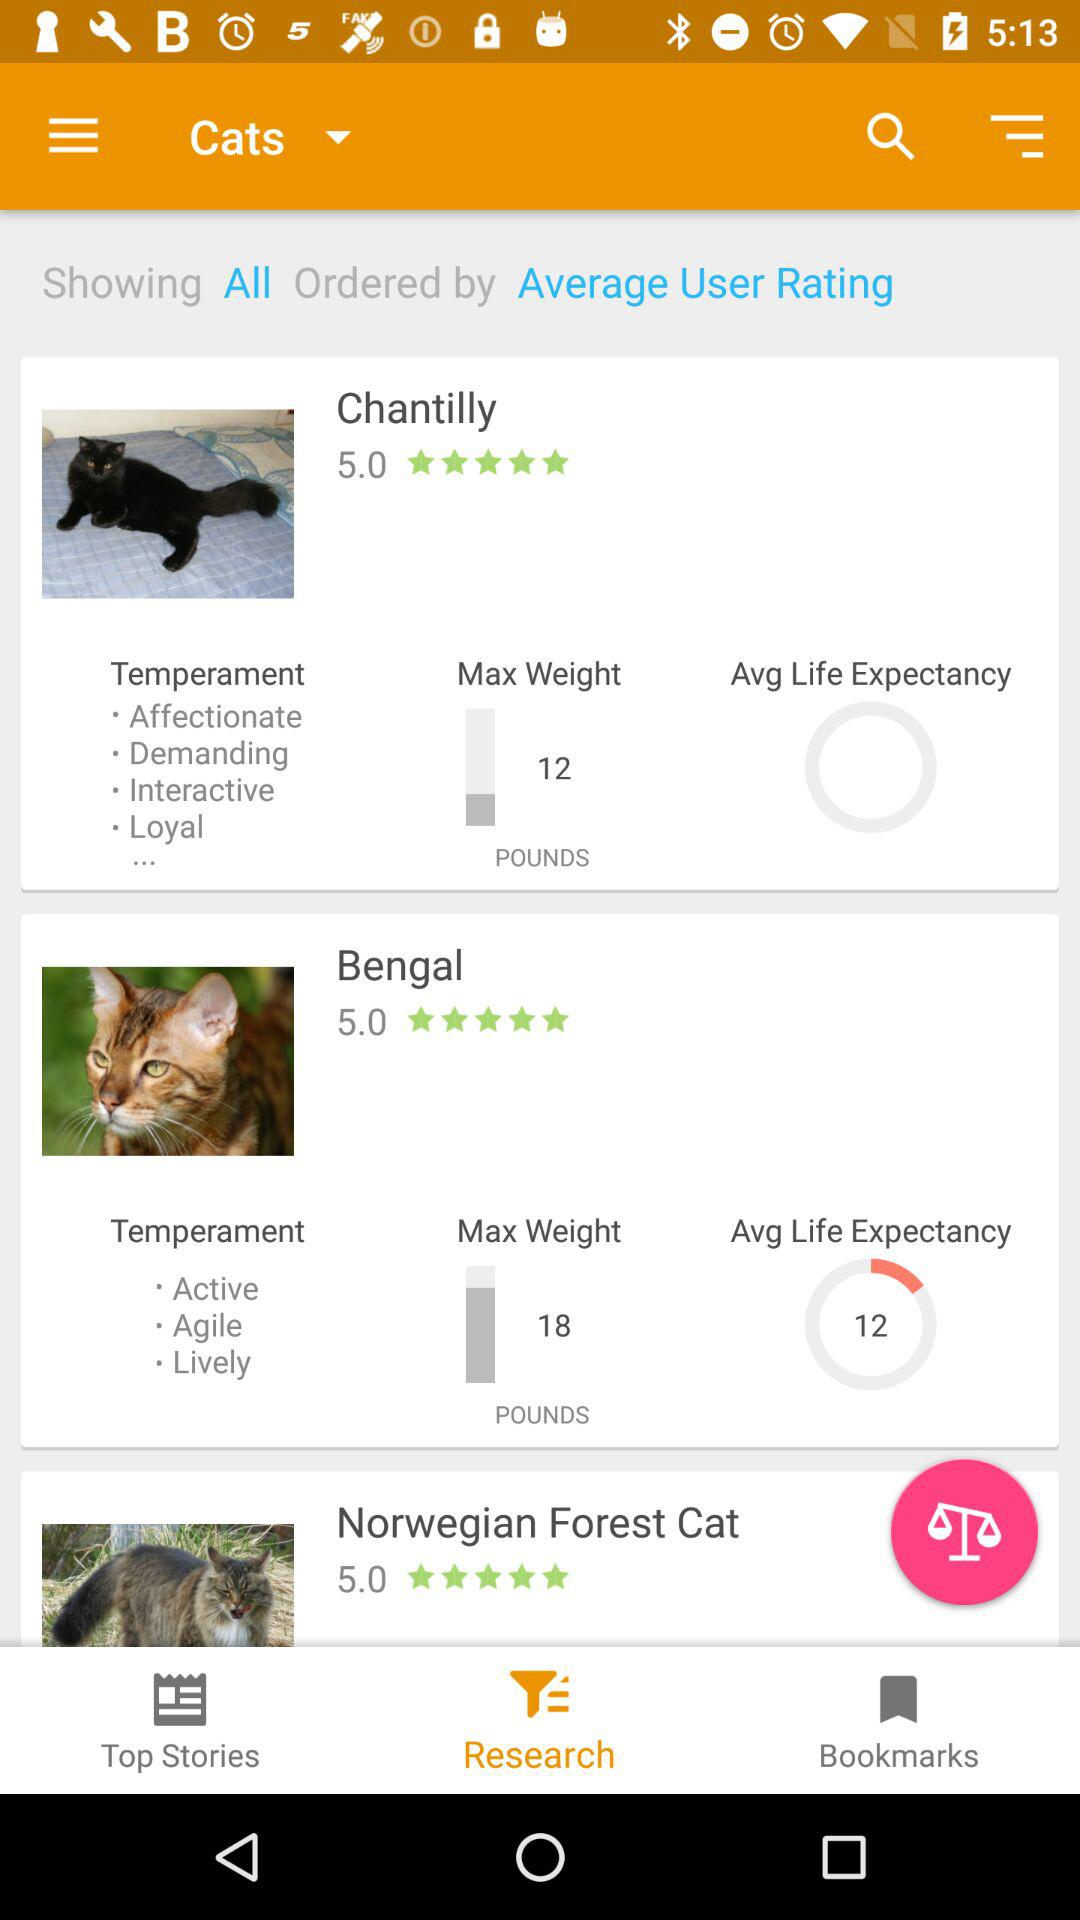What is the rating of Chantilly? The rating is 5 stars. 